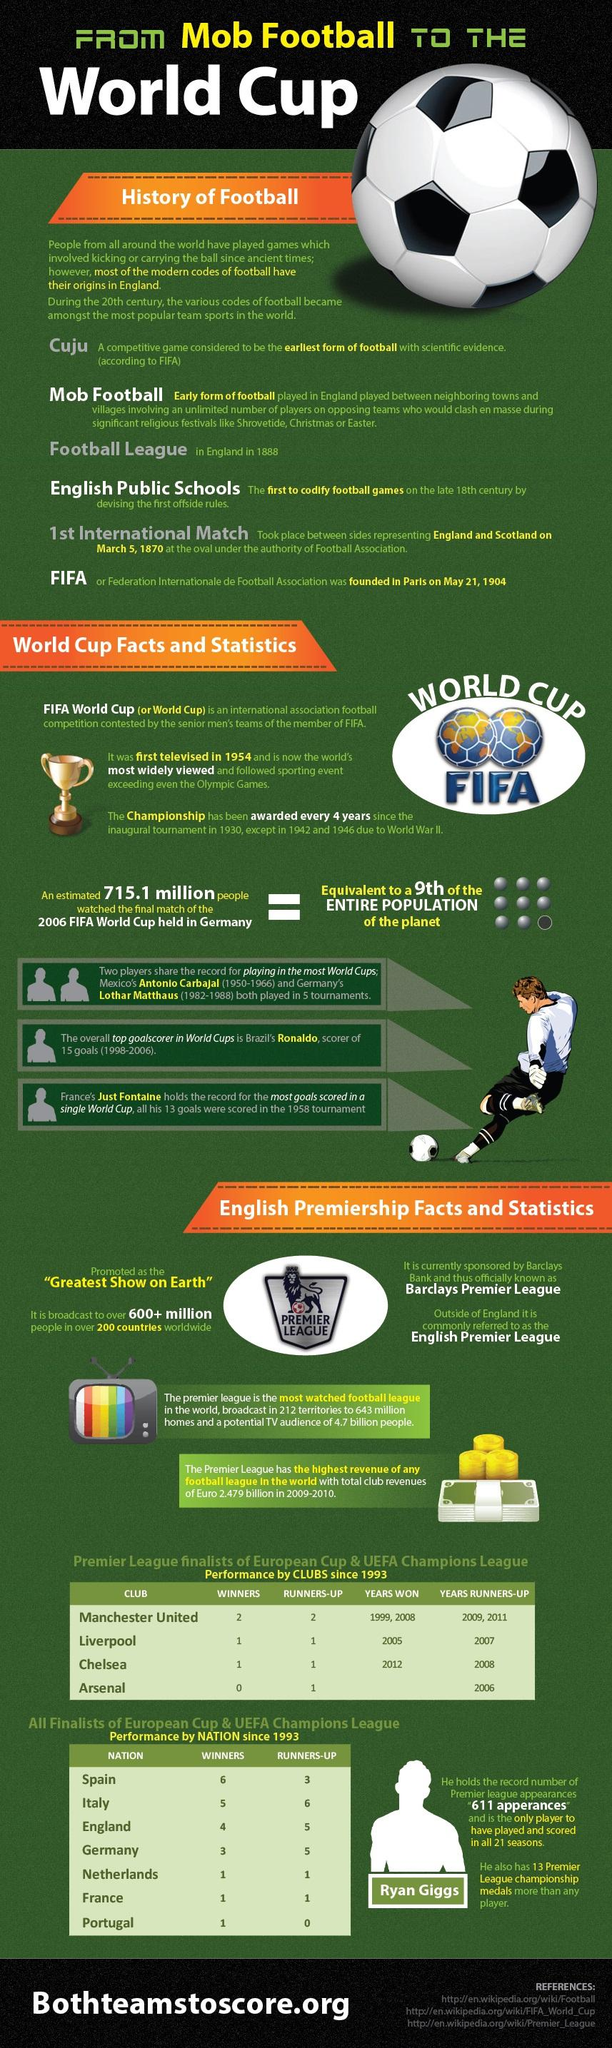List a handful of essential elements in this visual. Barclays Bank is currently the sponsor of the English Premier League. The English Premiership is promoted as the 'Greatest Show on Earth.' The FIFA World Cup was not held according to schedule in 1942 and 1946. The player Antonio Carbajal from Mexico has played in five World Cup tournaments. The final match of the 2006 FIFA World Cup, held in Germany, was expected to be watched by the equivalent of 1/9th of Earth's population. 